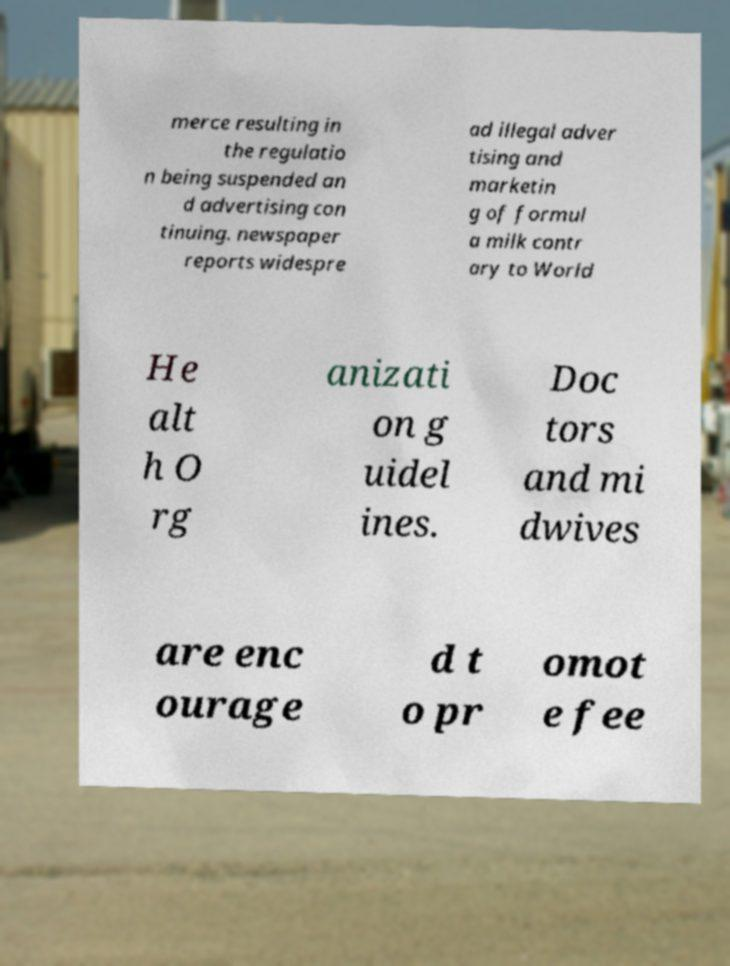I need the written content from this picture converted into text. Can you do that? merce resulting in the regulatio n being suspended an d advertising con tinuing. newspaper reports widespre ad illegal adver tising and marketin g of formul a milk contr ary to World He alt h O rg anizati on g uidel ines. Doc tors and mi dwives are enc ourage d t o pr omot e fee 